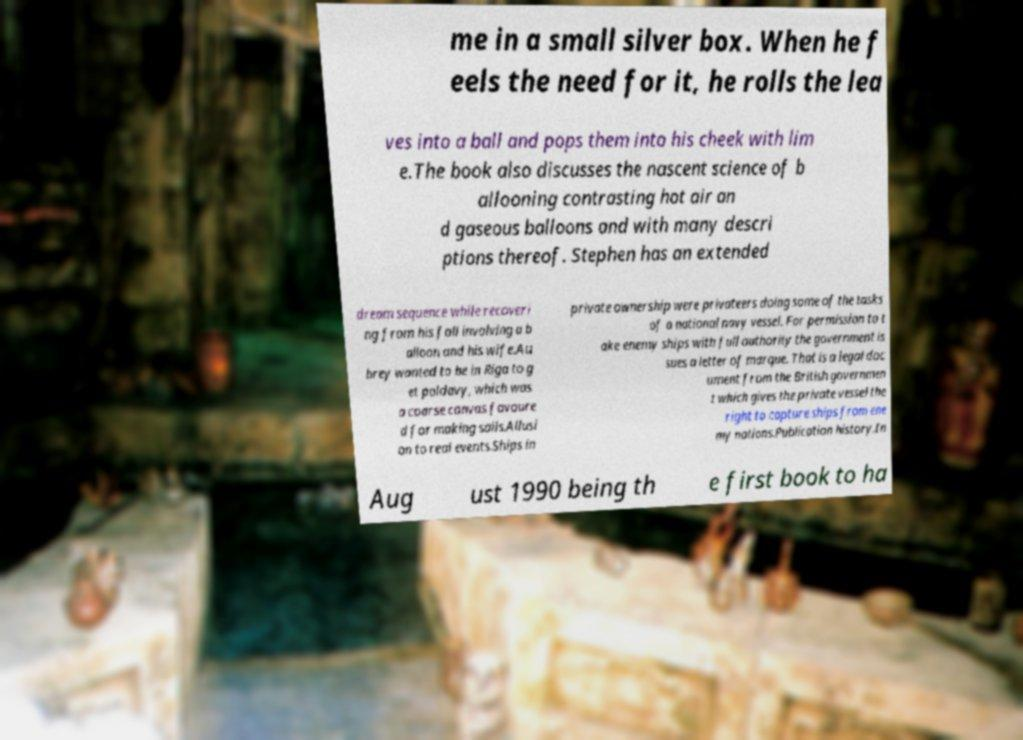There's text embedded in this image that I need extracted. Can you transcribe it verbatim? me in a small silver box. When he f eels the need for it, he rolls the lea ves into a ball and pops them into his cheek with lim e.The book also discusses the nascent science of b allooning contrasting hot air an d gaseous balloons and with many descri ptions thereof. Stephen has an extended dream sequence while recoveri ng from his fall involving a b alloon and his wife.Au brey wanted to be in Riga to g et poldavy, which was a coarse canvas favoure d for making sails.Allusi on to real events.Ships in private ownership were privateers doing some of the tasks of a national navy vessel. For permission to t ake enemy ships with full authority the government is sues a letter of marque. That is a legal doc ument from the British governmen t which gives the private vessel the right to capture ships from ene my nations.Publication history.In Aug ust 1990 being th e first book to ha 